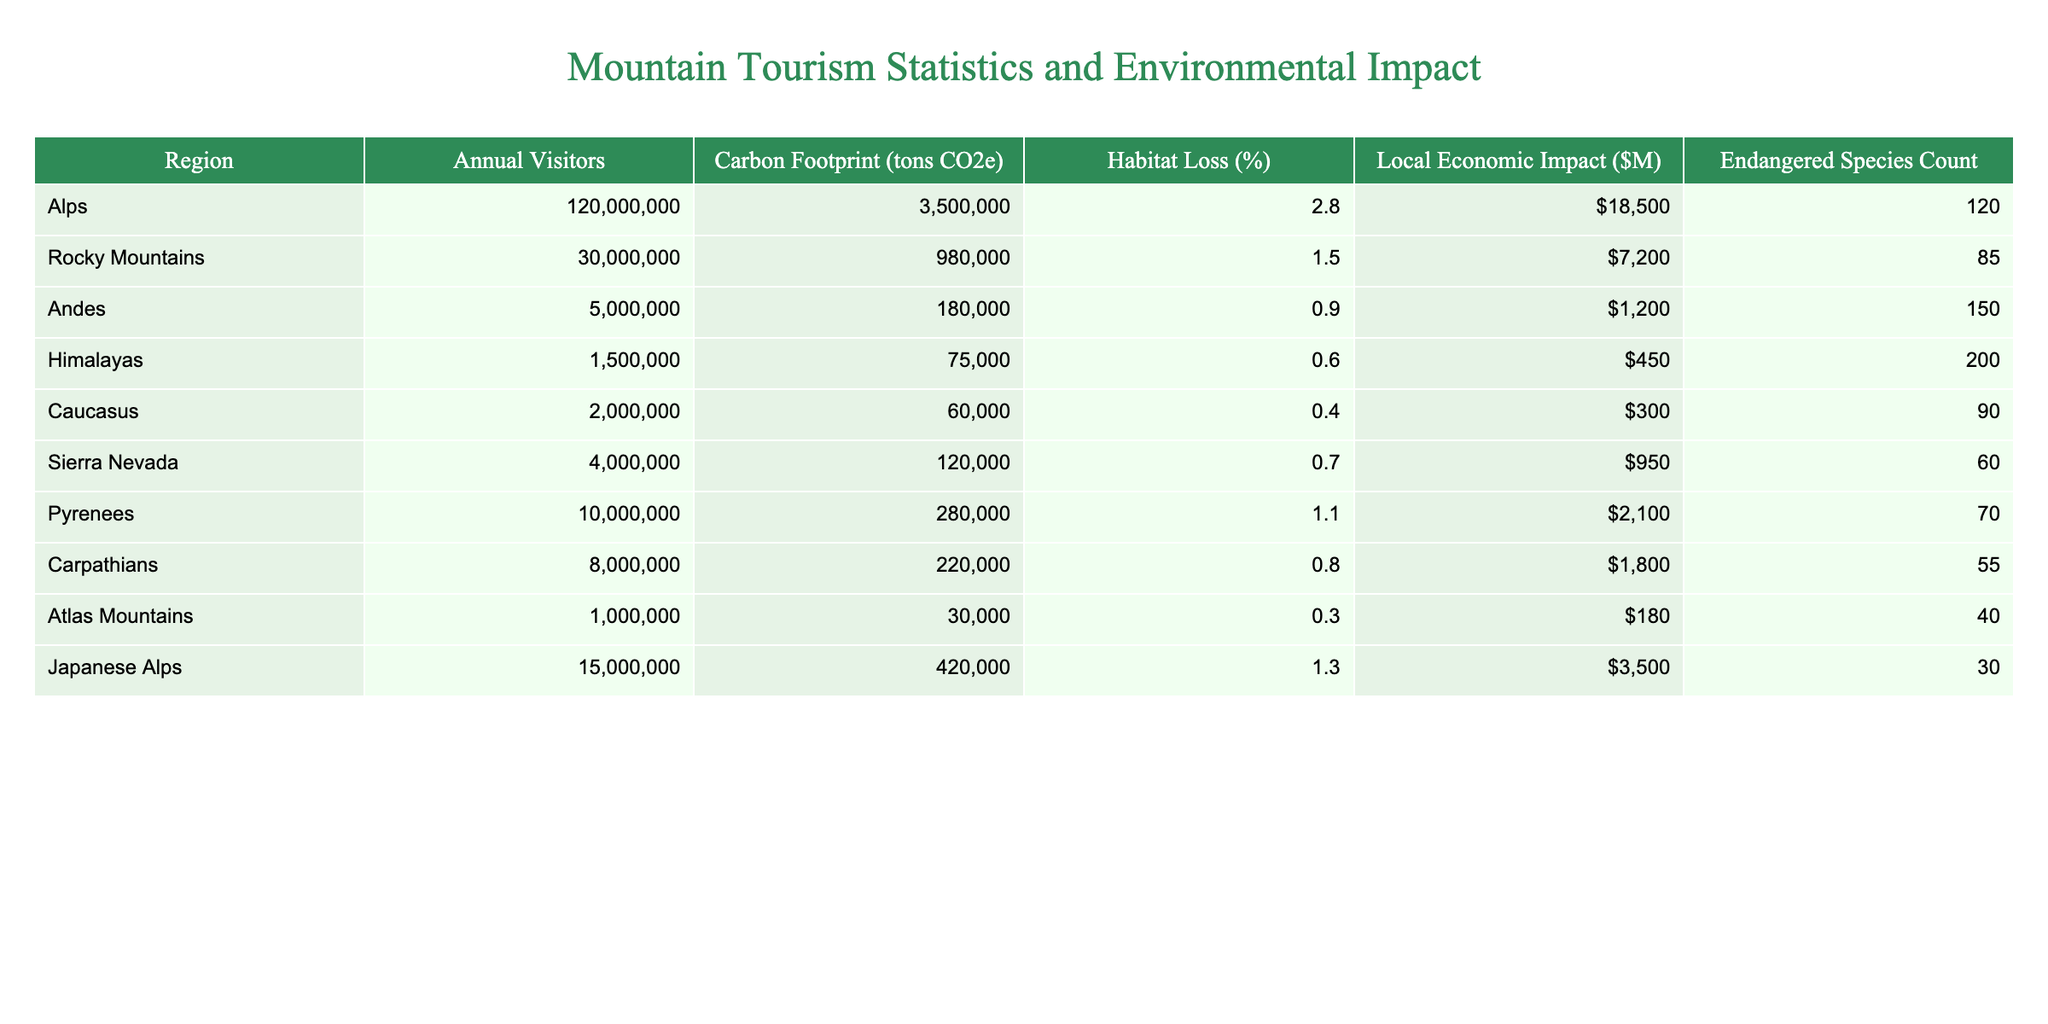What is the region with the highest number of annual visitors? By looking at the "Annual Visitors" column, the Alps have the highest value at 120,000,000 visitors.
Answer: Alps What is the carbon footprint of the Rocky Mountains? The "Carbon Footprint (tons CO2e)" for the Rocky Mountains is provided in the table as 980,000 tons CO2e.
Answer: 980,000 tons CO2e Which region has the highest percentage of habitat loss? The "Habitat Loss (%)" for each region indicates that the Alps have the highest percentage at 2.8%.
Answer: 2.8% What is the local economic impact of the Atlas Mountains? Referring to the "Local Economic Impact ($M)" column, the Atlas Mountains have a local economic impact of $180 million.
Answer: $180 million How many endangered species are there in the Himalayan region? The table lists the "Endangered Species Count" for the Himalayas as 200.
Answer: 200 What is the total annual visitor count for the Pyrenees and Sierra Nevada combined? Adding the annual visitors from the Pyrenees (10,000,000) and Sierra Nevada (4,000,000) gives a total of 10,000,000 + 4,000,000 = 14,000,000 visitors.
Answer: 14,000,000 Is the habitat loss in the Carpathians greater than that in the Caucasus? The habitat loss for the Carpathians is 0.8% and for the Caucasus is 0.4%, so habitat loss in the Carpathians is indeed greater.
Answer: Yes Which region has both a higher carbon footprint and local economic impact, the Rocky Mountains or the Andes? The Rocky Mountains have a carbon footprint of 980,000 tons CO2e and a local economic impact of $7200 million, while the Andes have a carbon footprint of 180,000 tons CO2e and a local economic impact of $1200 million. Comparing both metrics, the Rocky Mountains rank higher in both categories.
Answer: Rocky Mountains What is the average carbon footprint for all listed regions? To find the average, we sum the carbon foot prints (3,500,000 + 980,000 + 180,000 + 75,000 + 60,000 + 120,000 + 280,000 + 220,000 + 30,000 + 420,000 = 5,015,000) and divide by the number of regions (10), yielding an average carbon footprint of 5,015,000 / 10 = 501,500 tons CO2e.
Answer: 501,500 tons CO2e Are there more endangered species in regions with a higher local economic impact? Analyzing the data, it appears that regions with higher local economic impacts like the Alps (18500 million) have a larger number of endangered species (120), while regions with lower economic impacts like the Atlas Mountains ($180 million) have fewer endangered species (40). However, this trend varies and requires further statistical analysis to confirm causation.
Answer: No 